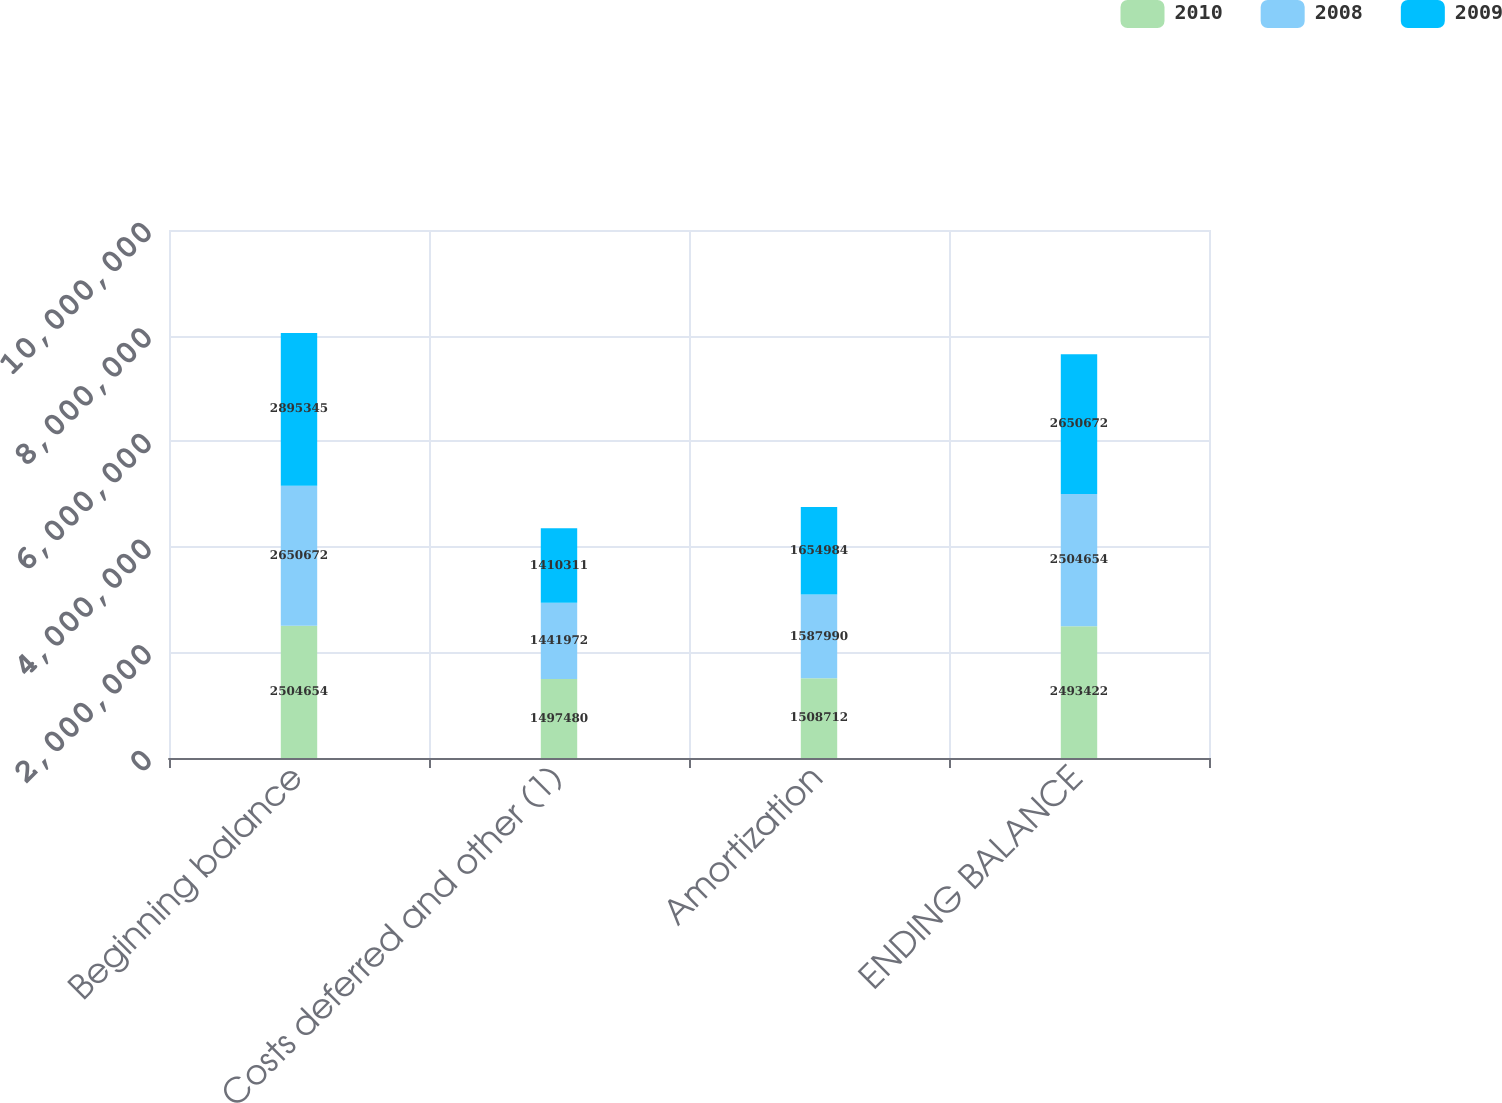Convert chart. <chart><loc_0><loc_0><loc_500><loc_500><stacked_bar_chart><ecel><fcel>Beginning balance<fcel>Costs deferred and other (1)<fcel>Amortization<fcel>ENDING BALANCE<nl><fcel>2010<fcel>2.50465e+06<fcel>1.49748e+06<fcel>1.50871e+06<fcel>2.49342e+06<nl><fcel>2008<fcel>2.65067e+06<fcel>1.44197e+06<fcel>1.58799e+06<fcel>2.50465e+06<nl><fcel>2009<fcel>2.89534e+06<fcel>1.41031e+06<fcel>1.65498e+06<fcel>2.65067e+06<nl></chart> 